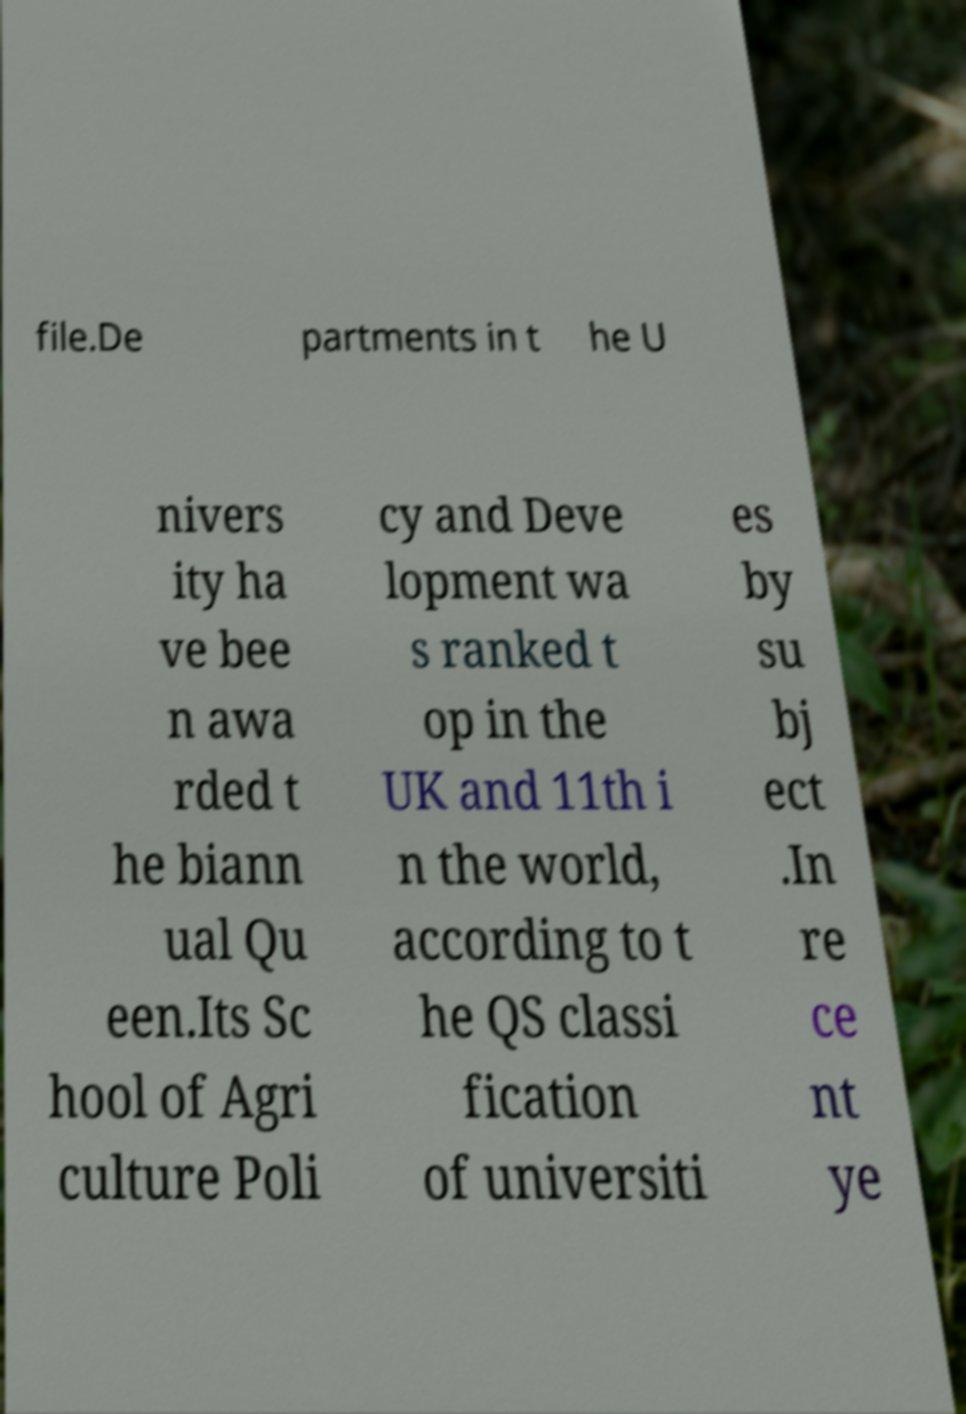What messages or text are displayed in this image? I need them in a readable, typed format. file.De partments in t he U nivers ity ha ve bee n awa rded t he biann ual Qu een.Its Sc hool of Agri culture Poli cy and Deve lopment wa s ranked t op in the UK and 11th i n the world, according to t he QS classi fication of universiti es by su bj ect .In re ce nt ye 